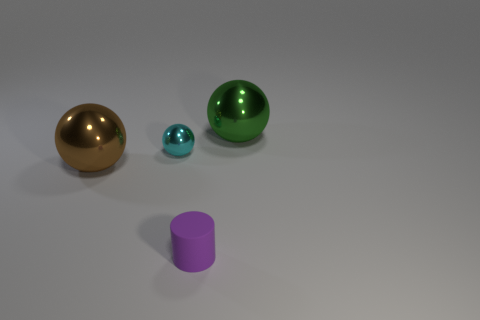Add 1 purple things. How many objects exist? 5 Subtract all balls. How many objects are left? 1 Add 3 small cyan metal balls. How many small cyan metal balls exist? 4 Subtract 1 cyan spheres. How many objects are left? 3 Subtract all small cyan objects. Subtract all red balls. How many objects are left? 3 Add 2 big objects. How many big objects are left? 4 